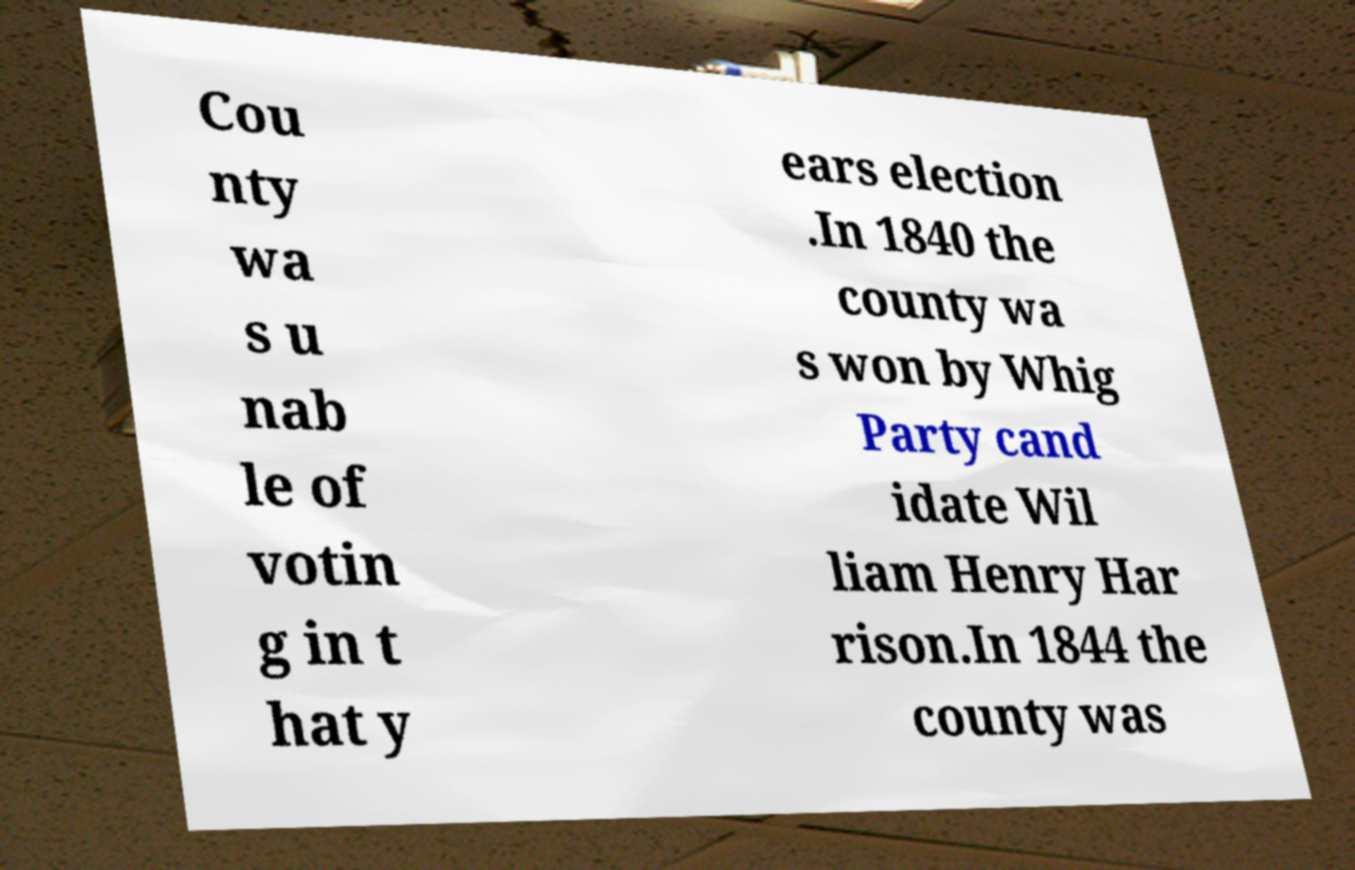Could you extract and type out the text from this image? Cou nty wa s u nab le of votin g in t hat y ears election .In 1840 the county wa s won by Whig Party cand idate Wil liam Henry Har rison.In 1844 the county was 